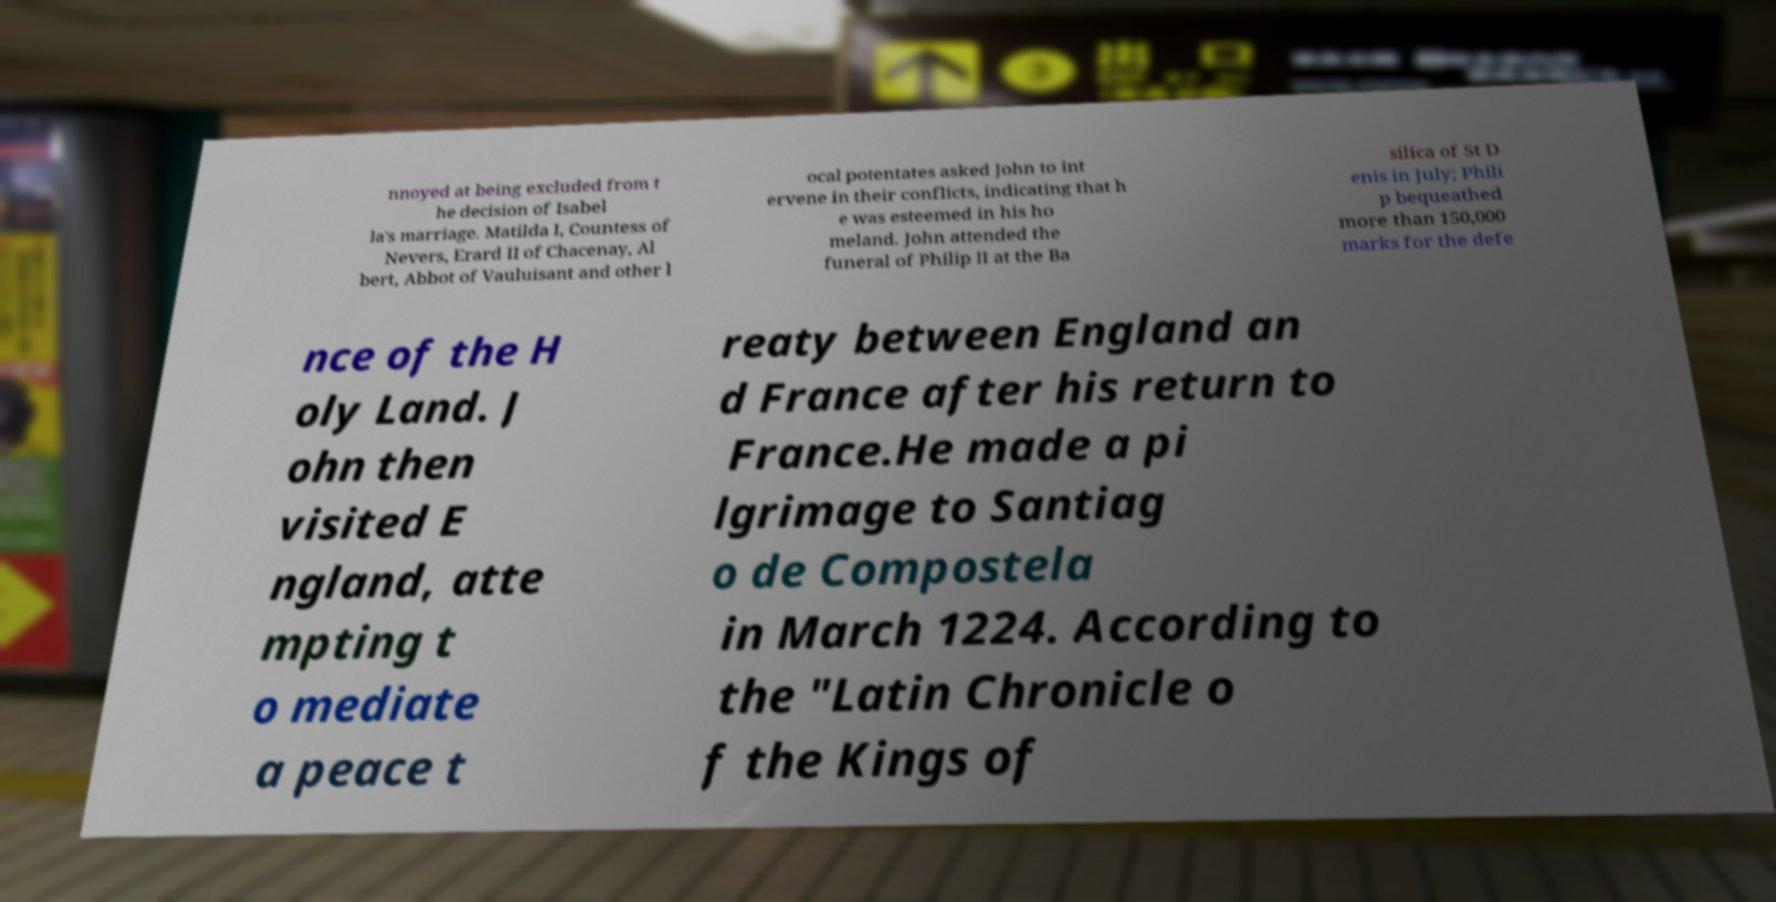Could you assist in decoding the text presented in this image and type it out clearly? nnoyed at being excluded from t he decision of Isabel la's marriage. Matilda I, Countess of Nevers, Erard II of Chacenay, Al bert, Abbot of Vauluisant and other l ocal potentates asked John to int ervene in their conflicts, indicating that h e was esteemed in his ho meland. John attended the funeral of Philip II at the Ba silica of St D enis in July; Phili p bequeathed more than 150,000 marks for the defe nce of the H oly Land. J ohn then visited E ngland, atte mpting t o mediate a peace t reaty between England an d France after his return to France.He made a pi lgrimage to Santiag o de Compostela in March 1224. According to the "Latin Chronicle o f the Kings of 